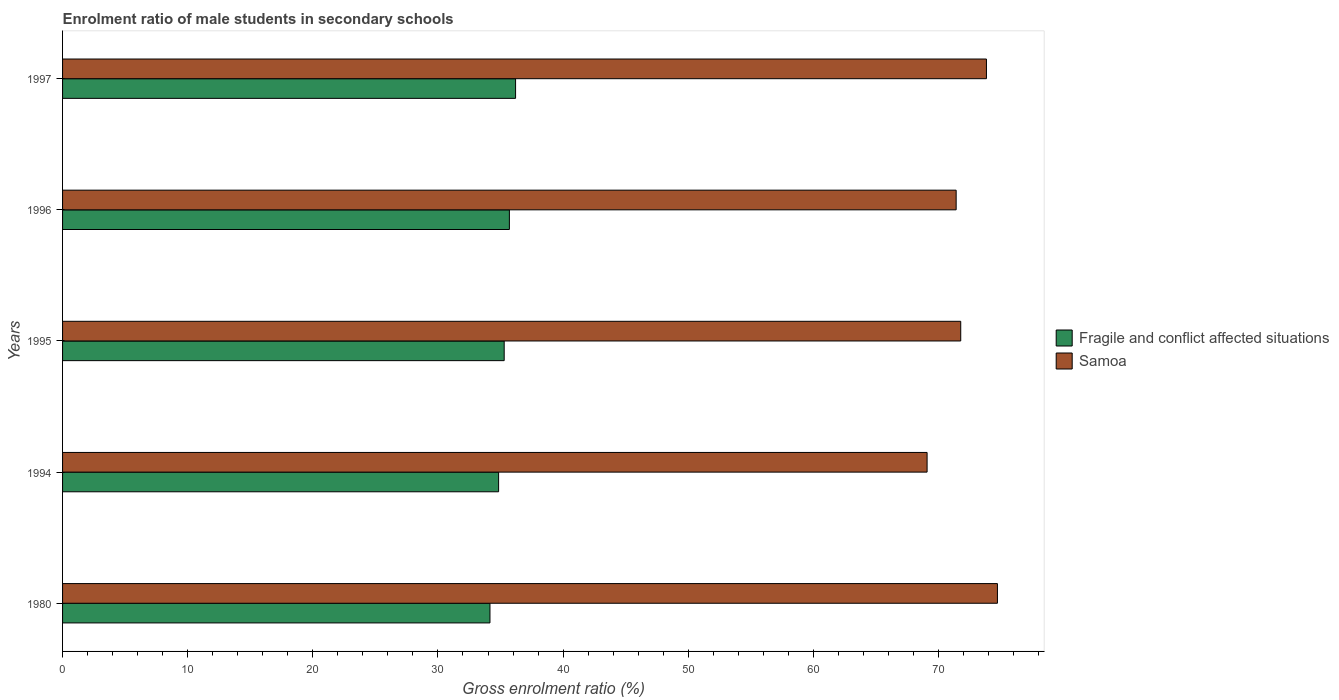Are the number of bars per tick equal to the number of legend labels?
Offer a very short reply. Yes. Are the number of bars on each tick of the Y-axis equal?
Your response must be concise. Yes. How many bars are there on the 4th tick from the bottom?
Keep it short and to the point. 2. What is the enrolment ratio of male students in secondary schools in Samoa in 1996?
Your response must be concise. 71.42. Across all years, what is the maximum enrolment ratio of male students in secondary schools in Samoa?
Offer a very short reply. 74.71. Across all years, what is the minimum enrolment ratio of male students in secondary schools in Samoa?
Your answer should be very brief. 69.09. In which year was the enrolment ratio of male students in secondary schools in Samoa minimum?
Offer a very short reply. 1994. What is the total enrolment ratio of male students in secondary schools in Fragile and conflict affected situations in the graph?
Your answer should be very brief. 176.21. What is the difference between the enrolment ratio of male students in secondary schools in Samoa in 1980 and that in 1997?
Your answer should be very brief. 0.88. What is the difference between the enrolment ratio of male students in secondary schools in Samoa in 1980 and the enrolment ratio of male students in secondary schools in Fragile and conflict affected situations in 1994?
Keep it short and to the point. 39.87. What is the average enrolment ratio of male students in secondary schools in Samoa per year?
Offer a terse response. 72.17. In the year 1980, what is the difference between the enrolment ratio of male students in secondary schools in Samoa and enrolment ratio of male students in secondary schools in Fragile and conflict affected situations?
Provide a short and direct response. 40.56. What is the ratio of the enrolment ratio of male students in secondary schools in Samoa in 1980 to that in 1997?
Your answer should be compact. 1.01. Is the enrolment ratio of male students in secondary schools in Fragile and conflict affected situations in 1980 less than that in 1995?
Give a very brief answer. Yes. Is the difference between the enrolment ratio of male students in secondary schools in Samoa in 1980 and 1997 greater than the difference between the enrolment ratio of male students in secondary schools in Fragile and conflict affected situations in 1980 and 1997?
Ensure brevity in your answer.  Yes. What is the difference between the highest and the second highest enrolment ratio of male students in secondary schools in Fragile and conflict affected situations?
Ensure brevity in your answer.  0.49. What is the difference between the highest and the lowest enrolment ratio of male students in secondary schools in Fragile and conflict affected situations?
Provide a succinct answer. 2.05. In how many years, is the enrolment ratio of male students in secondary schools in Samoa greater than the average enrolment ratio of male students in secondary schools in Samoa taken over all years?
Provide a short and direct response. 2. Is the sum of the enrolment ratio of male students in secondary schools in Samoa in 1996 and 1997 greater than the maximum enrolment ratio of male students in secondary schools in Fragile and conflict affected situations across all years?
Provide a short and direct response. Yes. What does the 1st bar from the top in 1996 represents?
Make the answer very short. Samoa. What does the 2nd bar from the bottom in 1980 represents?
Your answer should be compact. Samoa. How many bars are there?
Your response must be concise. 10. How many years are there in the graph?
Offer a very short reply. 5. What is the difference between two consecutive major ticks on the X-axis?
Your answer should be very brief. 10. Are the values on the major ticks of X-axis written in scientific E-notation?
Your answer should be compact. No. Does the graph contain grids?
Make the answer very short. No. How are the legend labels stacked?
Offer a terse response. Vertical. What is the title of the graph?
Provide a succinct answer. Enrolment ratio of male students in secondary schools. Does "Samoa" appear as one of the legend labels in the graph?
Give a very brief answer. Yes. What is the Gross enrolment ratio (%) of Fragile and conflict affected situations in 1980?
Make the answer very short. 34.16. What is the Gross enrolment ratio (%) in Samoa in 1980?
Provide a short and direct response. 74.71. What is the Gross enrolment ratio (%) of Fragile and conflict affected situations in 1994?
Your answer should be very brief. 34.85. What is the Gross enrolment ratio (%) in Samoa in 1994?
Keep it short and to the point. 69.09. What is the Gross enrolment ratio (%) of Fragile and conflict affected situations in 1995?
Offer a terse response. 35.29. What is the Gross enrolment ratio (%) of Samoa in 1995?
Offer a very short reply. 71.78. What is the Gross enrolment ratio (%) in Fragile and conflict affected situations in 1996?
Offer a very short reply. 35.71. What is the Gross enrolment ratio (%) of Samoa in 1996?
Provide a succinct answer. 71.42. What is the Gross enrolment ratio (%) in Fragile and conflict affected situations in 1997?
Your answer should be compact. 36.2. What is the Gross enrolment ratio (%) in Samoa in 1997?
Your answer should be compact. 73.84. Across all years, what is the maximum Gross enrolment ratio (%) in Fragile and conflict affected situations?
Ensure brevity in your answer.  36.2. Across all years, what is the maximum Gross enrolment ratio (%) of Samoa?
Offer a terse response. 74.71. Across all years, what is the minimum Gross enrolment ratio (%) in Fragile and conflict affected situations?
Keep it short and to the point. 34.16. Across all years, what is the minimum Gross enrolment ratio (%) of Samoa?
Your answer should be compact. 69.09. What is the total Gross enrolment ratio (%) of Fragile and conflict affected situations in the graph?
Ensure brevity in your answer.  176.21. What is the total Gross enrolment ratio (%) in Samoa in the graph?
Offer a very short reply. 360.84. What is the difference between the Gross enrolment ratio (%) in Fragile and conflict affected situations in 1980 and that in 1994?
Provide a short and direct response. -0.69. What is the difference between the Gross enrolment ratio (%) in Samoa in 1980 and that in 1994?
Ensure brevity in your answer.  5.62. What is the difference between the Gross enrolment ratio (%) of Fragile and conflict affected situations in 1980 and that in 1995?
Make the answer very short. -1.14. What is the difference between the Gross enrolment ratio (%) of Samoa in 1980 and that in 1995?
Keep it short and to the point. 2.93. What is the difference between the Gross enrolment ratio (%) in Fragile and conflict affected situations in 1980 and that in 1996?
Keep it short and to the point. -1.55. What is the difference between the Gross enrolment ratio (%) of Samoa in 1980 and that in 1996?
Make the answer very short. 3.3. What is the difference between the Gross enrolment ratio (%) of Fragile and conflict affected situations in 1980 and that in 1997?
Keep it short and to the point. -2.05. What is the difference between the Gross enrolment ratio (%) of Samoa in 1980 and that in 1997?
Offer a terse response. 0.88. What is the difference between the Gross enrolment ratio (%) of Fragile and conflict affected situations in 1994 and that in 1995?
Your answer should be compact. -0.45. What is the difference between the Gross enrolment ratio (%) in Samoa in 1994 and that in 1995?
Provide a succinct answer. -2.69. What is the difference between the Gross enrolment ratio (%) of Fragile and conflict affected situations in 1994 and that in 1996?
Your answer should be compact. -0.86. What is the difference between the Gross enrolment ratio (%) of Samoa in 1994 and that in 1996?
Your answer should be very brief. -2.32. What is the difference between the Gross enrolment ratio (%) in Fragile and conflict affected situations in 1994 and that in 1997?
Your answer should be compact. -1.36. What is the difference between the Gross enrolment ratio (%) in Samoa in 1994 and that in 1997?
Give a very brief answer. -4.74. What is the difference between the Gross enrolment ratio (%) in Fragile and conflict affected situations in 1995 and that in 1996?
Keep it short and to the point. -0.42. What is the difference between the Gross enrolment ratio (%) in Samoa in 1995 and that in 1996?
Keep it short and to the point. 0.37. What is the difference between the Gross enrolment ratio (%) in Fragile and conflict affected situations in 1995 and that in 1997?
Make the answer very short. -0.91. What is the difference between the Gross enrolment ratio (%) in Samoa in 1995 and that in 1997?
Give a very brief answer. -2.05. What is the difference between the Gross enrolment ratio (%) of Fragile and conflict affected situations in 1996 and that in 1997?
Offer a very short reply. -0.49. What is the difference between the Gross enrolment ratio (%) of Samoa in 1996 and that in 1997?
Give a very brief answer. -2.42. What is the difference between the Gross enrolment ratio (%) in Fragile and conflict affected situations in 1980 and the Gross enrolment ratio (%) in Samoa in 1994?
Your answer should be very brief. -34.94. What is the difference between the Gross enrolment ratio (%) of Fragile and conflict affected situations in 1980 and the Gross enrolment ratio (%) of Samoa in 1995?
Keep it short and to the point. -37.62. What is the difference between the Gross enrolment ratio (%) of Fragile and conflict affected situations in 1980 and the Gross enrolment ratio (%) of Samoa in 1996?
Keep it short and to the point. -37.26. What is the difference between the Gross enrolment ratio (%) in Fragile and conflict affected situations in 1980 and the Gross enrolment ratio (%) in Samoa in 1997?
Make the answer very short. -39.68. What is the difference between the Gross enrolment ratio (%) of Fragile and conflict affected situations in 1994 and the Gross enrolment ratio (%) of Samoa in 1995?
Your answer should be compact. -36.93. What is the difference between the Gross enrolment ratio (%) of Fragile and conflict affected situations in 1994 and the Gross enrolment ratio (%) of Samoa in 1996?
Offer a terse response. -36.57. What is the difference between the Gross enrolment ratio (%) of Fragile and conflict affected situations in 1994 and the Gross enrolment ratio (%) of Samoa in 1997?
Your response must be concise. -38.99. What is the difference between the Gross enrolment ratio (%) in Fragile and conflict affected situations in 1995 and the Gross enrolment ratio (%) in Samoa in 1996?
Give a very brief answer. -36.12. What is the difference between the Gross enrolment ratio (%) of Fragile and conflict affected situations in 1995 and the Gross enrolment ratio (%) of Samoa in 1997?
Your answer should be very brief. -38.54. What is the difference between the Gross enrolment ratio (%) of Fragile and conflict affected situations in 1996 and the Gross enrolment ratio (%) of Samoa in 1997?
Your response must be concise. -38.13. What is the average Gross enrolment ratio (%) in Fragile and conflict affected situations per year?
Offer a very short reply. 35.24. What is the average Gross enrolment ratio (%) in Samoa per year?
Ensure brevity in your answer.  72.17. In the year 1980, what is the difference between the Gross enrolment ratio (%) in Fragile and conflict affected situations and Gross enrolment ratio (%) in Samoa?
Offer a terse response. -40.56. In the year 1994, what is the difference between the Gross enrolment ratio (%) in Fragile and conflict affected situations and Gross enrolment ratio (%) in Samoa?
Provide a succinct answer. -34.24. In the year 1995, what is the difference between the Gross enrolment ratio (%) in Fragile and conflict affected situations and Gross enrolment ratio (%) in Samoa?
Offer a very short reply. -36.49. In the year 1996, what is the difference between the Gross enrolment ratio (%) of Fragile and conflict affected situations and Gross enrolment ratio (%) of Samoa?
Offer a terse response. -35.71. In the year 1997, what is the difference between the Gross enrolment ratio (%) in Fragile and conflict affected situations and Gross enrolment ratio (%) in Samoa?
Ensure brevity in your answer.  -37.63. What is the ratio of the Gross enrolment ratio (%) in Fragile and conflict affected situations in 1980 to that in 1994?
Provide a short and direct response. 0.98. What is the ratio of the Gross enrolment ratio (%) in Samoa in 1980 to that in 1994?
Make the answer very short. 1.08. What is the ratio of the Gross enrolment ratio (%) in Fragile and conflict affected situations in 1980 to that in 1995?
Your response must be concise. 0.97. What is the ratio of the Gross enrolment ratio (%) in Samoa in 1980 to that in 1995?
Your answer should be compact. 1.04. What is the ratio of the Gross enrolment ratio (%) in Fragile and conflict affected situations in 1980 to that in 1996?
Provide a short and direct response. 0.96. What is the ratio of the Gross enrolment ratio (%) of Samoa in 1980 to that in 1996?
Provide a succinct answer. 1.05. What is the ratio of the Gross enrolment ratio (%) in Fragile and conflict affected situations in 1980 to that in 1997?
Offer a terse response. 0.94. What is the ratio of the Gross enrolment ratio (%) of Samoa in 1980 to that in 1997?
Give a very brief answer. 1.01. What is the ratio of the Gross enrolment ratio (%) in Fragile and conflict affected situations in 1994 to that in 1995?
Provide a short and direct response. 0.99. What is the ratio of the Gross enrolment ratio (%) in Samoa in 1994 to that in 1995?
Give a very brief answer. 0.96. What is the ratio of the Gross enrolment ratio (%) in Fragile and conflict affected situations in 1994 to that in 1996?
Your answer should be very brief. 0.98. What is the ratio of the Gross enrolment ratio (%) of Samoa in 1994 to that in 1996?
Ensure brevity in your answer.  0.97. What is the ratio of the Gross enrolment ratio (%) of Fragile and conflict affected situations in 1994 to that in 1997?
Give a very brief answer. 0.96. What is the ratio of the Gross enrolment ratio (%) of Samoa in 1994 to that in 1997?
Provide a succinct answer. 0.94. What is the ratio of the Gross enrolment ratio (%) in Fragile and conflict affected situations in 1995 to that in 1996?
Your answer should be compact. 0.99. What is the ratio of the Gross enrolment ratio (%) of Samoa in 1995 to that in 1996?
Make the answer very short. 1.01. What is the ratio of the Gross enrolment ratio (%) of Fragile and conflict affected situations in 1995 to that in 1997?
Offer a very short reply. 0.97. What is the ratio of the Gross enrolment ratio (%) in Samoa in 1995 to that in 1997?
Your answer should be compact. 0.97. What is the ratio of the Gross enrolment ratio (%) of Fragile and conflict affected situations in 1996 to that in 1997?
Provide a short and direct response. 0.99. What is the ratio of the Gross enrolment ratio (%) of Samoa in 1996 to that in 1997?
Offer a terse response. 0.97. What is the difference between the highest and the second highest Gross enrolment ratio (%) in Fragile and conflict affected situations?
Keep it short and to the point. 0.49. What is the difference between the highest and the second highest Gross enrolment ratio (%) in Samoa?
Provide a succinct answer. 0.88. What is the difference between the highest and the lowest Gross enrolment ratio (%) in Fragile and conflict affected situations?
Your answer should be very brief. 2.05. What is the difference between the highest and the lowest Gross enrolment ratio (%) of Samoa?
Provide a short and direct response. 5.62. 